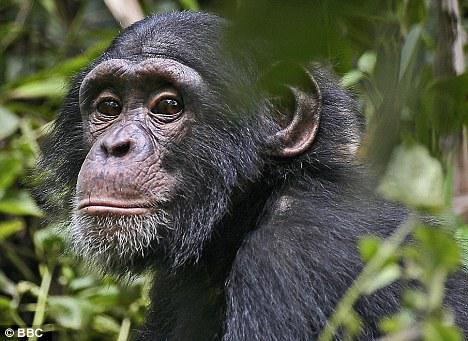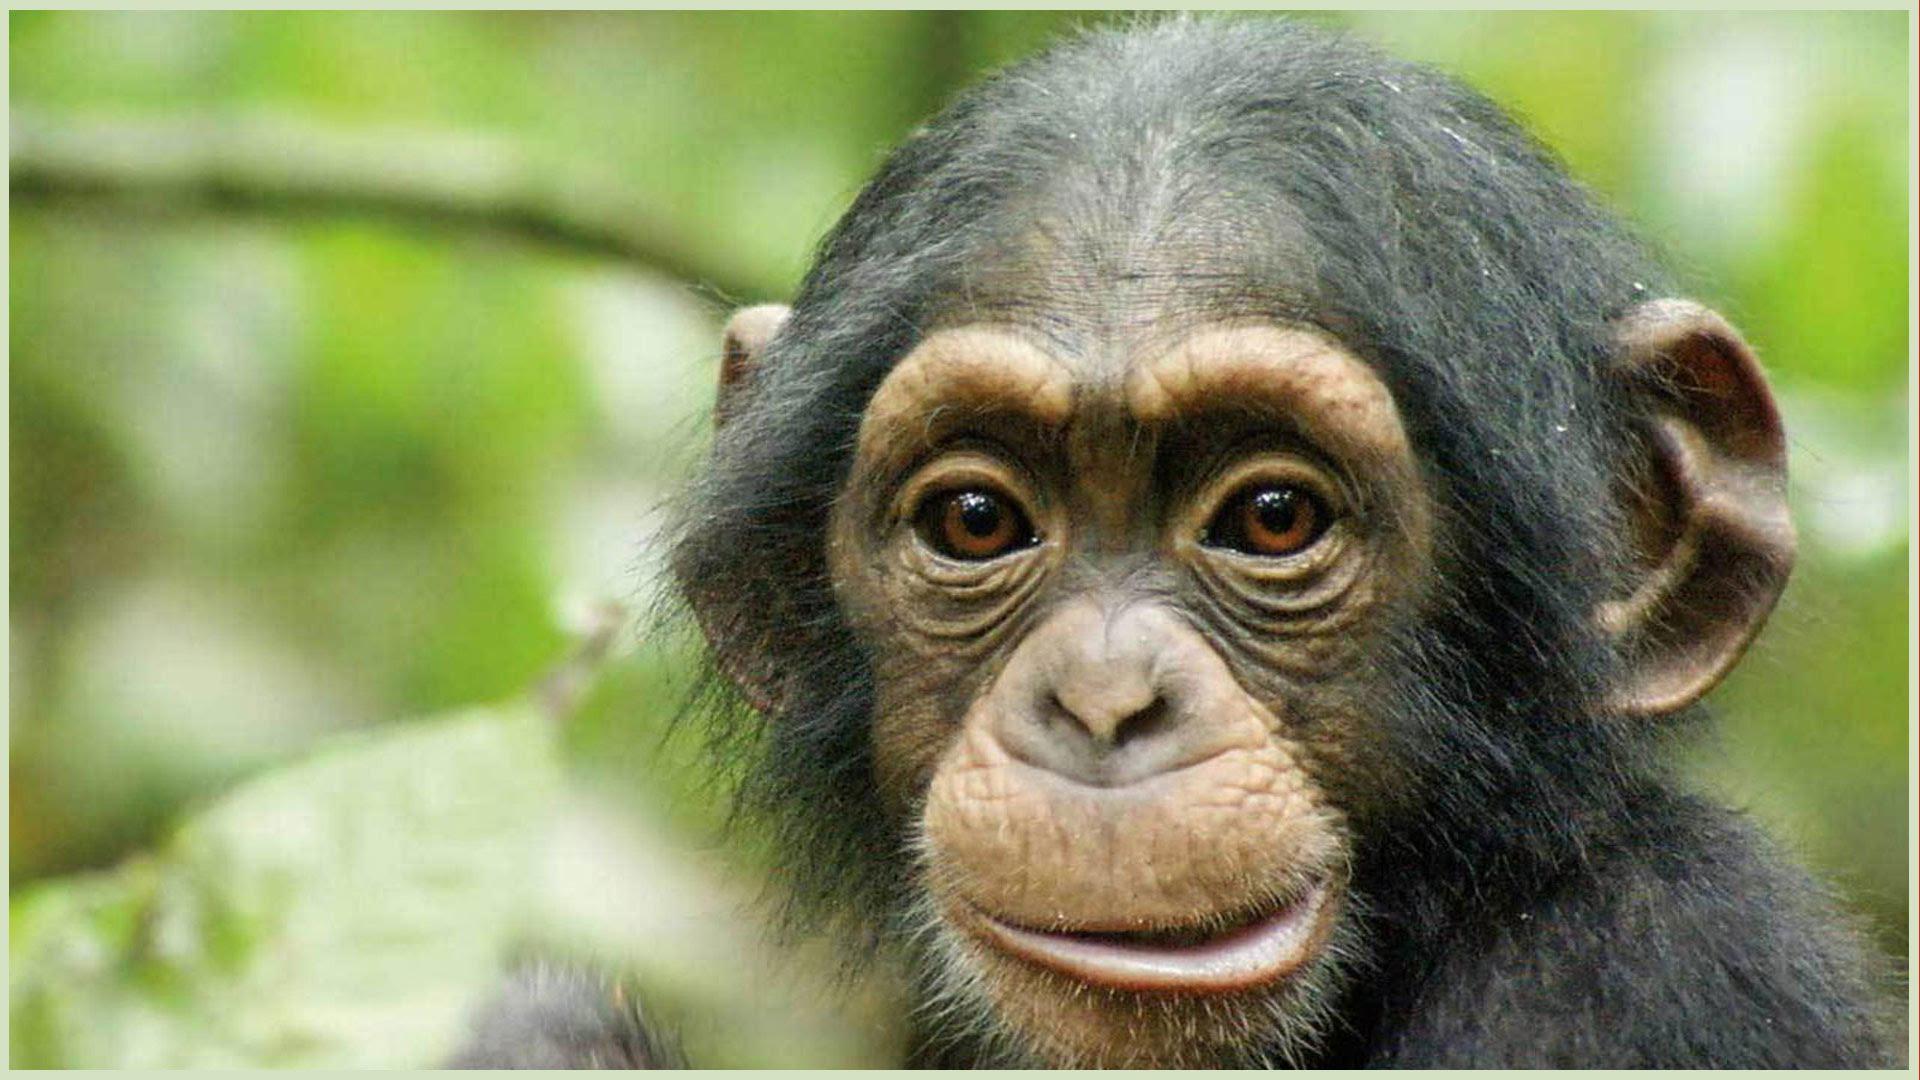The first image is the image on the left, the second image is the image on the right. Considering the images on both sides, is "One of the images contains a monkey that is holding its finger on its mouth." valid? Answer yes or no. No. 